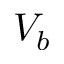<formula> <loc_0><loc_0><loc_500><loc_500>V _ { b }</formula> 